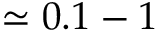<formula> <loc_0><loc_0><loc_500><loc_500>\simeq 0 . 1 - 1</formula> 